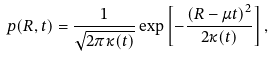Convert formula to latex. <formula><loc_0><loc_0><loc_500><loc_500>p ( R , t ) = \frac { 1 } { \sqrt { 2 \pi \kappa ( t ) } } \exp \left [ - \frac { \left ( R - \mu t \right ) ^ { 2 } } { 2 \kappa ( t ) } \right ] ,</formula> 